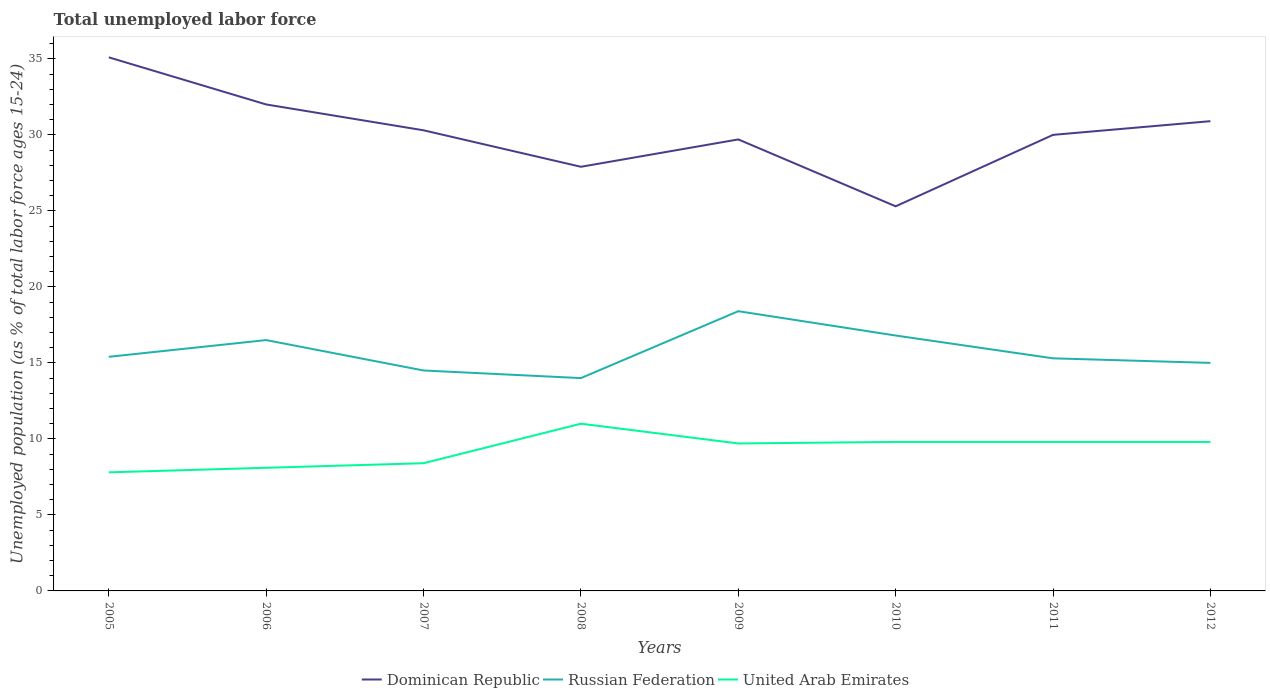Does the line corresponding to United Arab Emirates intersect with the line corresponding to Dominican Republic?
Your answer should be compact. No. Across all years, what is the maximum percentage of unemployed population in in Dominican Republic?
Your answer should be very brief. 25.3. In which year was the percentage of unemployed population in in United Arab Emirates maximum?
Give a very brief answer. 2005. What is the total percentage of unemployed population in in Dominican Republic in the graph?
Offer a terse response. 1.7. What is the difference between the highest and the second highest percentage of unemployed population in in Dominican Republic?
Make the answer very short. 9.8. Is the percentage of unemployed population in in United Arab Emirates strictly greater than the percentage of unemployed population in in Dominican Republic over the years?
Your answer should be compact. Yes. What is the difference between two consecutive major ticks on the Y-axis?
Offer a very short reply. 5. Does the graph contain grids?
Offer a very short reply. No. Where does the legend appear in the graph?
Make the answer very short. Bottom center. What is the title of the graph?
Provide a short and direct response. Total unemployed labor force. Does "Mexico" appear as one of the legend labels in the graph?
Your answer should be compact. No. What is the label or title of the Y-axis?
Your answer should be compact. Unemployed population (as % of total labor force ages 15-24). What is the Unemployed population (as % of total labor force ages 15-24) of Dominican Republic in 2005?
Offer a very short reply. 35.1. What is the Unemployed population (as % of total labor force ages 15-24) in Russian Federation in 2005?
Give a very brief answer. 15.4. What is the Unemployed population (as % of total labor force ages 15-24) in United Arab Emirates in 2005?
Make the answer very short. 7.8. What is the Unemployed population (as % of total labor force ages 15-24) in Russian Federation in 2006?
Give a very brief answer. 16.5. What is the Unemployed population (as % of total labor force ages 15-24) in United Arab Emirates in 2006?
Give a very brief answer. 8.1. What is the Unemployed population (as % of total labor force ages 15-24) of Dominican Republic in 2007?
Your response must be concise. 30.3. What is the Unemployed population (as % of total labor force ages 15-24) of Russian Federation in 2007?
Make the answer very short. 14.5. What is the Unemployed population (as % of total labor force ages 15-24) of United Arab Emirates in 2007?
Your answer should be compact. 8.4. What is the Unemployed population (as % of total labor force ages 15-24) of Dominican Republic in 2008?
Give a very brief answer. 27.9. What is the Unemployed population (as % of total labor force ages 15-24) in United Arab Emirates in 2008?
Provide a succinct answer. 11. What is the Unemployed population (as % of total labor force ages 15-24) in Dominican Republic in 2009?
Your answer should be very brief. 29.7. What is the Unemployed population (as % of total labor force ages 15-24) in Russian Federation in 2009?
Your answer should be very brief. 18.4. What is the Unemployed population (as % of total labor force ages 15-24) in United Arab Emirates in 2009?
Your response must be concise. 9.7. What is the Unemployed population (as % of total labor force ages 15-24) of Dominican Republic in 2010?
Keep it short and to the point. 25.3. What is the Unemployed population (as % of total labor force ages 15-24) of Russian Federation in 2010?
Your answer should be compact. 16.8. What is the Unemployed population (as % of total labor force ages 15-24) in United Arab Emirates in 2010?
Offer a very short reply. 9.8. What is the Unemployed population (as % of total labor force ages 15-24) of Dominican Republic in 2011?
Offer a terse response. 30. What is the Unemployed population (as % of total labor force ages 15-24) in Russian Federation in 2011?
Your response must be concise. 15.3. What is the Unemployed population (as % of total labor force ages 15-24) in United Arab Emirates in 2011?
Offer a very short reply. 9.8. What is the Unemployed population (as % of total labor force ages 15-24) in Dominican Republic in 2012?
Ensure brevity in your answer.  30.9. What is the Unemployed population (as % of total labor force ages 15-24) in Russian Federation in 2012?
Your response must be concise. 15. What is the Unemployed population (as % of total labor force ages 15-24) in United Arab Emirates in 2012?
Make the answer very short. 9.8. Across all years, what is the maximum Unemployed population (as % of total labor force ages 15-24) of Dominican Republic?
Offer a terse response. 35.1. Across all years, what is the maximum Unemployed population (as % of total labor force ages 15-24) of Russian Federation?
Give a very brief answer. 18.4. Across all years, what is the maximum Unemployed population (as % of total labor force ages 15-24) in United Arab Emirates?
Offer a terse response. 11. Across all years, what is the minimum Unemployed population (as % of total labor force ages 15-24) in Dominican Republic?
Provide a succinct answer. 25.3. Across all years, what is the minimum Unemployed population (as % of total labor force ages 15-24) in United Arab Emirates?
Offer a terse response. 7.8. What is the total Unemployed population (as % of total labor force ages 15-24) of Dominican Republic in the graph?
Give a very brief answer. 241.2. What is the total Unemployed population (as % of total labor force ages 15-24) of Russian Federation in the graph?
Provide a succinct answer. 125.9. What is the total Unemployed population (as % of total labor force ages 15-24) in United Arab Emirates in the graph?
Your response must be concise. 74.4. What is the difference between the Unemployed population (as % of total labor force ages 15-24) in Russian Federation in 2005 and that in 2006?
Offer a terse response. -1.1. What is the difference between the Unemployed population (as % of total labor force ages 15-24) of Russian Federation in 2005 and that in 2008?
Offer a terse response. 1.4. What is the difference between the Unemployed population (as % of total labor force ages 15-24) in United Arab Emirates in 2005 and that in 2008?
Provide a succinct answer. -3.2. What is the difference between the Unemployed population (as % of total labor force ages 15-24) of Russian Federation in 2005 and that in 2009?
Make the answer very short. -3. What is the difference between the Unemployed population (as % of total labor force ages 15-24) of United Arab Emirates in 2005 and that in 2009?
Ensure brevity in your answer.  -1.9. What is the difference between the Unemployed population (as % of total labor force ages 15-24) in Dominican Republic in 2005 and that in 2010?
Your response must be concise. 9.8. What is the difference between the Unemployed population (as % of total labor force ages 15-24) of Russian Federation in 2005 and that in 2010?
Offer a terse response. -1.4. What is the difference between the Unemployed population (as % of total labor force ages 15-24) in United Arab Emirates in 2005 and that in 2010?
Your response must be concise. -2. What is the difference between the Unemployed population (as % of total labor force ages 15-24) of Russian Federation in 2005 and that in 2011?
Your response must be concise. 0.1. What is the difference between the Unemployed population (as % of total labor force ages 15-24) of Dominican Republic in 2006 and that in 2007?
Your response must be concise. 1.7. What is the difference between the Unemployed population (as % of total labor force ages 15-24) in Russian Federation in 2006 and that in 2007?
Your answer should be compact. 2. What is the difference between the Unemployed population (as % of total labor force ages 15-24) in Russian Federation in 2006 and that in 2008?
Keep it short and to the point. 2.5. What is the difference between the Unemployed population (as % of total labor force ages 15-24) of United Arab Emirates in 2006 and that in 2008?
Keep it short and to the point. -2.9. What is the difference between the Unemployed population (as % of total labor force ages 15-24) in Russian Federation in 2006 and that in 2010?
Ensure brevity in your answer.  -0.3. What is the difference between the Unemployed population (as % of total labor force ages 15-24) of Russian Federation in 2006 and that in 2011?
Make the answer very short. 1.2. What is the difference between the Unemployed population (as % of total labor force ages 15-24) in United Arab Emirates in 2006 and that in 2011?
Provide a succinct answer. -1.7. What is the difference between the Unemployed population (as % of total labor force ages 15-24) in Russian Federation in 2006 and that in 2012?
Offer a terse response. 1.5. What is the difference between the Unemployed population (as % of total labor force ages 15-24) in Russian Federation in 2007 and that in 2008?
Keep it short and to the point. 0.5. What is the difference between the Unemployed population (as % of total labor force ages 15-24) in Dominican Republic in 2007 and that in 2010?
Your answer should be compact. 5. What is the difference between the Unemployed population (as % of total labor force ages 15-24) in United Arab Emirates in 2007 and that in 2010?
Ensure brevity in your answer.  -1.4. What is the difference between the Unemployed population (as % of total labor force ages 15-24) in Dominican Republic in 2007 and that in 2011?
Ensure brevity in your answer.  0.3. What is the difference between the Unemployed population (as % of total labor force ages 15-24) in Russian Federation in 2007 and that in 2011?
Your answer should be very brief. -0.8. What is the difference between the Unemployed population (as % of total labor force ages 15-24) of Dominican Republic in 2007 and that in 2012?
Ensure brevity in your answer.  -0.6. What is the difference between the Unemployed population (as % of total labor force ages 15-24) of Dominican Republic in 2008 and that in 2009?
Offer a very short reply. -1.8. What is the difference between the Unemployed population (as % of total labor force ages 15-24) of Russian Federation in 2008 and that in 2009?
Your answer should be very brief. -4.4. What is the difference between the Unemployed population (as % of total labor force ages 15-24) in United Arab Emirates in 2008 and that in 2009?
Ensure brevity in your answer.  1.3. What is the difference between the Unemployed population (as % of total labor force ages 15-24) of United Arab Emirates in 2008 and that in 2010?
Keep it short and to the point. 1.2. What is the difference between the Unemployed population (as % of total labor force ages 15-24) in Dominican Republic in 2008 and that in 2012?
Offer a very short reply. -3. What is the difference between the Unemployed population (as % of total labor force ages 15-24) in Russian Federation in 2008 and that in 2012?
Ensure brevity in your answer.  -1. What is the difference between the Unemployed population (as % of total labor force ages 15-24) of United Arab Emirates in 2008 and that in 2012?
Keep it short and to the point. 1.2. What is the difference between the Unemployed population (as % of total labor force ages 15-24) of Dominican Republic in 2009 and that in 2010?
Your answer should be compact. 4.4. What is the difference between the Unemployed population (as % of total labor force ages 15-24) of Russian Federation in 2009 and that in 2010?
Your response must be concise. 1.6. What is the difference between the Unemployed population (as % of total labor force ages 15-24) in Dominican Republic in 2009 and that in 2011?
Offer a very short reply. -0.3. What is the difference between the Unemployed population (as % of total labor force ages 15-24) of United Arab Emirates in 2009 and that in 2011?
Provide a succinct answer. -0.1. What is the difference between the Unemployed population (as % of total labor force ages 15-24) in Dominican Republic in 2009 and that in 2012?
Provide a succinct answer. -1.2. What is the difference between the Unemployed population (as % of total labor force ages 15-24) of United Arab Emirates in 2009 and that in 2012?
Offer a very short reply. -0.1. What is the difference between the Unemployed population (as % of total labor force ages 15-24) of Dominican Republic in 2010 and that in 2011?
Your answer should be compact. -4.7. What is the difference between the Unemployed population (as % of total labor force ages 15-24) in United Arab Emirates in 2010 and that in 2011?
Your answer should be very brief. 0. What is the difference between the Unemployed population (as % of total labor force ages 15-24) of Dominican Republic in 2010 and that in 2012?
Your response must be concise. -5.6. What is the difference between the Unemployed population (as % of total labor force ages 15-24) in Dominican Republic in 2011 and that in 2012?
Provide a short and direct response. -0.9. What is the difference between the Unemployed population (as % of total labor force ages 15-24) of Russian Federation in 2011 and that in 2012?
Keep it short and to the point. 0.3. What is the difference between the Unemployed population (as % of total labor force ages 15-24) of Dominican Republic in 2005 and the Unemployed population (as % of total labor force ages 15-24) of United Arab Emirates in 2006?
Your answer should be compact. 27. What is the difference between the Unemployed population (as % of total labor force ages 15-24) in Dominican Republic in 2005 and the Unemployed population (as % of total labor force ages 15-24) in Russian Federation in 2007?
Make the answer very short. 20.6. What is the difference between the Unemployed population (as % of total labor force ages 15-24) of Dominican Republic in 2005 and the Unemployed population (as % of total labor force ages 15-24) of United Arab Emirates in 2007?
Your answer should be very brief. 26.7. What is the difference between the Unemployed population (as % of total labor force ages 15-24) in Dominican Republic in 2005 and the Unemployed population (as % of total labor force ages 15-24) in Russian Federation in 2008?
Your response must be concise. 21.1. What is the difference between the Unemployed population (as % of total labor force ages 15-24) of Dominican Republic in 2005 and the Unemployed population (as % of total labor force ages 15-24) of United Arab Emirates in 2008?
Your answer should be compact. 24.1. What is the difference between the Unemployed population (as % of total labor force ages 15-24) in Russian Federation in 2005 and the Unemployed population (as % of total labor force ages 15-24) in United Arab Emirates in 2008?
Offer a very short reply. 4.4. What is the difference between the Unemployed population (as % of total labor force ages 15-24) in Dominican Republic in 2005 and the Unemployed population (as % of total labor force ages 15-24) in Russian Federation in 2009?
Keep it short and to the point. 16.7. What is the difference between the Unemployed population (as % of total labor force ages 15-24) of Dominican Republic in 2005 and the Unemployed population (as % of total labor force ages 15-24) of United Arab Emirates in 2009?
Your response must be concise. 25.4. What is the difference between the Unemployed population (as % of total labor force ages 15-24) in Russian Federation in 2005 and the Unemployed population (as % of total labor force ages 15-24) in United Arab Emirates in 2009?
Provide a succinct answer. 5.7. What is the difference between the Unemployed population (as % of total labor force ages 15-24) of Dominican Republic in 2005 and the Unemployed population (as % of total labor force ages 15-24) of United Arab Emirates in 2010?
Offer a very short reply. 25.3. What is the difference between the Unemployed population (as % of total labor force ages 15-24) of Dominican Republic in 2005 and the Unemployed population (as % of total labor force ages 15-24) of Russian Federation in 2011?
Provide a succinct answer. 19.8. What is the difference between the Unemployed population (as % of total labor force ages 15-24) in Dominican Republic in 2005 and the Unemployed population (as % of total labor force ages 15-24) in United Arab Emirates in 2011?
Provide a succinct answer. 25.3. What is the difference between the Unemployed population (as % of total labor force ages 15-24) of Russian Federation in 2005 and the Unemployed population (as % of total labor force ages 15-24) of United Arab Emirates in 2011?
Your answer should be very brief. 5.6. What is the difference between the Unemployed population (as % of total labor force ages 15-24) in Dominican Republic in 2005 and the Unemployed population (as % of total labor force ages 15-24) in Russian Federation in 2012?
Provide a short and direct response. 20.1. What is the difference between the Unemployed population (as % of total labor force ages 15-24) in Dominican Republic in 2005 and the Unemployed population (as % of total labor force ages 15-24) in United Arab Emirates in 2012?
Your response must be concise. 25.3. What is the difference between the Unemployed population (as % of total labor force ages 15-24) in Russian Federation in 2005 and the Unemployed population (as % of total labor force ages 15-24) in United Arab Emirates in 2012?
Keep it short and to the point. 5.6. What is the difference between the Unemployed population (as % of total labor force ages 15-24) in Dominican Republic in 2006 and the Unemployed population (as % of total labor force ages 15-24) in Russian Federation in 2007?
Give a very brief answer. 17.5. What is the difference between the Unemployed population (as % of total labor force ages 15-24) in Dominican Republic in 2006 and the Unemployed population (as % of total labor force ages 15-24) in United Arab Emirates in 2007?
Your answer should be very brief. 23.6. What is the difference between the Unemployed population (as % of total labor force ages 15-24) of Russian Federation in 2006 and the Unemployed population (as % of total labor force ages 15-24) of United Arab Emirates in 2007?
Provide a succinct answer. 8.1. What is the difference between the Unemployed population (as % of total labor force ages 15-24) in Dominican Republic in 2006 and the Unemployed population (as % of total labor force ages 15-24) in Russian Federation in 2009?
Provide a short and direct response. 13.6. What is the difference between the Unemployed population (as % of total labor force ages 15-24) of Dominican Republic in 2006 and the Unemployed population (as % of total labor force ages 15-24) of United Arab Emirates in 2009?
Ensure brevity in your answer.  22.3. What is the difference between the Unemployed population (as % of total labor force ages 15-24) in Russian Federation in 2006 and the Unemployed population (as % of total labor force ages 15-24) in United Arab Emirates in 2009?
Provide a succinct answer. 6.8. What is the difference between the Unemployed population (as % of total labor force ages 15-24) in Dominican Republic in 2006 and the Unemployed population (as % of total labor force ages 15-24) in United Arab Emirates in 2010?
Ensure brevity in your answer.  22.2. What is the difference between the Unemployed population (as % of total labor force ages 15-24) in Russian Federation in 2006 and the Unemployed population (as % of total labor force ages 15-24) in United Arab Emirates in 2010?
Your answer should be compact. 6.7. What is the difference between the Unemployed population (as % of total labor force ages 15-24) in Dominican Republic in 2006 and the Unemployed population (as % of total labor force ages 15-24) in Russian Federation in 2011?
Provide a succinct answer. 16.7. What is the difference between the Unemployed population (as % of total labor force ages 15-24) of Dominican Republic in 2006 and the Unemployed population (as % of total labor force ages 15-24) of United Arab Emirates in 2011?
Offer a very short reply. 22.2. What is the difference between the Unemployed population (as % of total labor force ages 15-24) in Russian Federation in 2006 and the Unemployed population (as % of total labor force ages 15-24) in United Arab Emirates in 2011?
Your answer should be very brief. 6.7. What is the difference between the Unemployed population (as % of total labor force ages 15-24) in Dominican Republic in 2006 and the Unemployed population (as % of total labor force ages 15-24) in Russian Federation in 2012?
Ensure brevity in your answer.  17. What is the difference between the Unemployed population (as % of total labor force ages 15-24) in Dominican Republic in 2006 and the Unemployed population (as % of total labor force ages 15-24) in United Arab Emirates in 2012?
Your response must be concise. 22.2. What is the difference between the Unemployed population (as % of total labor force ages 15-24) in Russian Federation in 2006 and the Unemployed population (as % of total labor force ages 15-24) in United Arab Emirates in 2012?
Keep it short and to the point. 6.7. What is the difference between the Unemployed population (as % of total labor force ages 15-24) of Dominican Republic in 2007 and the Unemployed population (as % of total labor force ages 15-24) of United Arab Emirates in 2008?
Ensure brevity in your answer.  19.3. What is the difference between the Unemployed population (as % of total labor force ages 15-24) of Dominican Republic in 2007 and the Unemployed population (as % of total labor force ages 15-24) of United Arab Emirates in 2009?
Provide a short and direct response. 20.6. What is the difference between the Unemployed population (as % of total labor force ages 15-24) in Dominican Republic in 2007 and the Unemployed population (as % of total labor force ages 15-24) in Russian Federation in 2010?
Your response must be concise. 13.5. What is the difference between the Unemployed population (as % of total labor force ages 15-24) of Dominican Republic in 2007 and the Unemployed population (as % of total labor force ages 15-24) of United Arab Emirates in 2010?
Keep it short and to the point. 20.5. What is the difference between the Unemployed population (as % of total labor force ages 15-24) in Dominican Republic in 2007 and the Unemployed population (as % of total labor force ages 15-24) in Russian Federation in 2012?
Your answer should be very brief. 15.3. What is the difference between the Unemployed population (as % of total labor force ages 15-24) in Dominican Republic in 2008 and the Unemployed population (as % of total labor force ages 15-24) in Russian Federation in 2010?
Make the answer very short. 11.1. What is the difference between the Unemployed population (as % of total labor force ages 15-24) of Russian Federation in 2008 and the Unemployed population (as % of total labor force ages 15-24) of United Arab Emirates in 2010?
Your answer should be very brief. 4.2. What is the difference between the Unemployed population (as % of total labor force ages 15-24) in Dominican Republic in 2008 and the Unemployed population (as % of total labor force ages 15-24) in United Arab Emirates in 2011?
Make the answer very short. 18.1. What is the difference between the Unemployed population (as % of total labor force ages 15-24) in Russian Federation in 2008 and the Unemployed population (as % of total labor force ages 15-24) in United Arab Emirates in 2011?
Offer a very short reply. 4.2. What is the difference between the Unemployed population (as % of total labor force ages 15-24) in Russian Federation in 2008 and the Unemployed population (as % of total labor force ages 15-24) in United Arab Emirates in 2012?
Your answer should be compact. 4.2. What is the difference between the Unemployed population (as % of total labor force ages 15-24) of Dominican Republic in 2009 and the Unemployed population (as % of total labor force ages 15-24) of United Arab Emirates in 2010?
Your answer should be very brief. 19.9. What is the difference between the Unemployed population (as % of total labor force ages 15-24) of Russian Federation in 2009 and the Unemployed population (as % of total labor force ages 15-24) of United Arab Emirates in 2010?
Your answer should be compact. 8.6. What is the difference between the Unemployed population (as % of total labor force ages 15-24) of Dominican Republic in 2009 and the Unemployed population (as % of total labor force ages 15-24) of United Arab Emirates in 2012?
Offer a terse response. 19.9. What is the difference between the Unemployed population (as % of total labor force ages 15-24) in Russian Federation in 2009 and the Unemployed population (as % of total labor force ages 15-24) in United Arab Emirates in 2012?
Offer a terse response. 8.6. What is the difference between the Unemployed population (as % of total labor force ages 15-24) in Dominican Republic in 2010 and the Unemployed population (as % of total labor force ages 15-24) in Russian Federation in 2011?
Ensure brevity in your answer.  10. What is the difference between the Unemployed population (as % of total labor force ages 15-24) in Dominican Republic in 2010 and the Unemployed population (as % of total labor force ages 15-24) in United Arab Emirates in 2011?
Give a very brief answer. 15.5. What is the difference between the Unemployed population (as % of total labor force ages 15-24) in Dominican Republic in 2011 and the Unemployed population (as % of total labor force ages 15-24) in United Arab Emirates in 2012?
Offer a very short reply. 20.2. What is the difference between the Unemployed population (as % of total labor force ages 15-24) in Russian Federation in 2011 and the Unemployed population (as % of total labor force ages 15-24) in United Arab Emirates in 2012?
Ensure brevity in your answer.  5.5. What is the average Unemployed population (as % of total labor force ages 15-24) in Dominican Republic per year?
Offer a terse response. 30.15. What is the average Unemployed population (as % of total labor force ages 15-24) in Russian Federation per year?
Provide a succinct answer. 15.74. What is the average Unemployed population (as % of total labor force ages 15-24) in United Arab Emirates per year?
Offer a terse response. 9.3. In the year 2005, what is the difference between the Unemployed population (as % of total labor force ages 15-24) in Dominican Republic and Unemployed population (as % of total labor force ages 15-24) in United Arab Emirates?
Provide a succinct answer. 27.3. In the year 2006, what is the difference between the Unemployed population (as % of total labor force ages 15-24) of Dominican Republic and Unemployed population (as % of total labor force ages 15-24) of United Arab Emirates?
Provide a succinct answer. 23.9. In the year 2006, what is the difference between the Unemployed population (as % of total labor force ages 15-24) in Russian Federation and Unemployed population (as % of total labor force ages 15-24) in United Arab Emirates?
Give a very brief answer. 8.4. In the year 2007, what is the difference between the Unemployed population (as % of total labor force ages 15-24) of Dominican Republic and Unemployed population (as % of total labor force ages 15-24) of Russian Federation?
Offer a very short reply. 15.8. In the year 2007, what is the difference between the Unemployed population (as % of total labor force ages 15-24) in Dominican Republic and Unemployed population (as % of total labor force ages 15-24) in United Arab Emirates?
Your answer should be very brief. 21.9. In the year 2007, what is the difference between the Unemployed population (as % of total labor force ages 15-24) in Russian Federation and Unemployed population (as % of total labor force ages 15-24) in United Arab Emirates?
Provide a succinct answer. 6.1. In the year 2008, what is the difference between the Unemployed population (as % of total labor force ages 15-24) in Dominican Republic and Unemployed population (as % of total labor force ages 15-24) in Russian Federation?
Give a very brief answer. 13.9. In the year 2009, what is the difference between the Unemployed population (as % of total labor force ages 15-24) in Dominican Republic and Unemployed population (as % of total labor force ages 15-24) in Russian Federation?
Provide a short and direct response. 11.3. In the year 2009, what is the difference between the Unemployed population (as % of total labor force ages 15-24) of Dominican Republic and Unemployed population (as % of total labor force ages 15-24) of United Arab Emirates?
Provide a short and direct response. 20. In the year 2009, what is the difference between the Unemployed population (as % of total labor force ages 15-24) of Russian Federation and Unemployed population (as % of total labor force ages 15-24) of United Arab Emirates?
Your response must be concise. 8.7. In the year 2011, what is the difference between the Unemployed population (as % of total labor force ages 15-24) in Dominican Republic and Unemployed population (as % of total labor force ages 15-24) in Russian Federation?
Offer a very short reply. 14.7. In the year 2011, what is the difference between the Unemployed population (as % of total labor force ages 15-24) in Dominican Republic and Unemployed population (as % of total labor force ages 15-24) in United Arab Emirates?
Provide a succinct answer. 20.2. In the year 2012, what is the difference between the Unemployed population (as % of total labor force ages 15-24) of Dominican Republic and Unemployed population (as % of total labor force ages 15-24) of United Arab Emirates?
Offer a terse response. 21.1. In the year 2012, what is the difference between the Unemployed population (as % of total labor force ages 15-24) of Russian Federation and Unemployed population (as % of total labor force ages 15-24) of United Arab Emirates?
Make the answer very short. 5.2. What is the ratio of the Unemployed population (as % of total labor force ages 15-24) of Dominican Republic in 2005 to that in 2006?
Your answer should be compact. 1.1. What is the ratio of the Unemployed population (as % of total labor force ages 15-24) in United Arab Emirates in 2005 to that in 2006?
Your response must be concise. 0.96. What is the ratio of the Unemployed population (as % of total labor force ages 15-24) of Dominican Republic in 2005 to that in 2007?
Your answer should be very brief. 1.16. What is the ratio of the Unemployed population (as % of total labor force ages 15-24) of Russian Federation in 2005 to that in 2007?
Your answer should be very brief. 1.06. What is the ratio of the Unemployed population (as % of total labor force ages 15-24) of United Arab Emirates in 2005 to that in 2007?
Give a very brief answer. 0.93. What is the ratio of the Unemployed population (as % of total labor force ages 15-24) in Dominican Republic in 2005 to that in 2008?
Your response must be concise. 1.26. What is the ratio of the Unemployed population (as % of total labor force ages 15-24) in United Arab Emirates in 2005 to that in 2008?
Give a very brief answer. 0.71. What is the ratio of the Unemployed population (as % of total labor force ages 15-24) of Dominican Republic in 2005 to that in 2009?
Give a very brief answer. 1.18. What is the ratio of the Unemployed population (as % of total labor force ages 15-24) in Russian Federation in 2005 to that in 2009?
Your response must be concise. 0.84. What is the ratio of the Unemployed population (as % of total labor force ages 15-24) in United Arab Emirates in 2005 to that in 2009?
Your answer should be compact. 0.8. What is the ratio of the Unemployed population (as % of total labor force ages 15-24) in Dominican Republic in 2005 to that in 2010?
Ensure brevity in your answer.  1.39. What is the ratio of the Unemployed population (as % of total labor force ages 15-24) in United Arab Emirates in 2005 to that in 2010?
Provide a short and direct response. 0.8. What is the ratio of the Unemployed population (as % of total labor force ages 15-24) of Dominican Republic in 2005 to that in 2011?
Your answer should be very brief. 1.17. What is the ratio of the Unemployed population (as % of total labor force ages 15-24) of Russian Federation in 2005 to that in 2011?
Give a very brief answer. 1.01. What is the ratio of the Unemployed population (as % of total labor force ages 15-24) of United Arab Emirates in 2005 to that in 2011?
Your response must be concise. 0.8. What is the ratio of the Unemployed population (as % of total labor force ages 15-24) of Dominican Republic in 2005 to that in 2012?
Provide a short and direct response. 1.14. What is the ratio of the Unemployed population (as % of total labor force ages 15-24) in Russian Federation in 2005 to that in 2012?
Keep it short and to the point. 1.03. What is the ratio of the Unemployed population (as % of total labor force ages 15-24) of United Arab Emirates in 2005 to that in 2012?
Ensure brevity in your answer.  0.8. What is the ratio of the Unemployed population (as % of total labor force ages 15-24) in Dominican Republic in 2006 to that in 2007?
Offer a terse response. 1.06. What is the ratio of the Unemployed population (as % of total labor force ages 15-24) of Russian Federation in 2006 to that in 2007?
Offer a terse response. 1.14. What is the ratio of the Unemployed population (as % of total labor force ages 15-24) in Dominican Republic in 2006 to that in 2008?
Give a very brief answer. 1.15. What is the ratio of the Unemployed population (as % of total labor force ages 15-24) in Russian Federation in 2006 to that in 2008?
Your answer should be very brief. 1.18. What is the ratio of the Unemployed population (as % of total labor force ages 15-24) in United Arab Emirates in 2006 to that in 2008?
Your answer should be compact. 0.74. What is the ratio of the Unemployed population (as % of total labor force ages 15-24) in Dominican Republic in 2006 to that in 2009?
Your response must be concise. 1.08. What is the ratio of the Unemployed population (as % of total labor force ages 15-24) in Russian Federation in 2006 to that in 2009?
Keep it short and to the point. 0.9. What is the ratio of the Unemployed population (as % of total labor force ages 15-24) of United Arab Emirates in 2006 to that in 2009?
Keep it short and to the point. 0.84. What is the ratio of the Unemployed population (as % of total labor force ages 15-24) in Dominican Republic in 2006 to that in 2010?
Offer a terse response. 1.26. What is the ratio of the Unemployed population (as % of total labor force ages 15-24) of Russian Federation in 2006 to that in 2010?
Keep it short and to the point. 0.98. What is the ratio of the Unemployed population (as % of total labor force ages 15-24) in United Arab Emirates in 2006 to that in 2010?
Your answer should be compact. 0.83. What is the ratio of the Unemployed population (as % of total labor force ages 15-24) in Dominican Republic in 2006 to that in 2011?
Offer a very short reply. 1.07. What is the ratio of the Unemployed population (as % of total labor force ages 15-24) of Russian Federation in 2006 to that in 2011?
Your response must be concise. 1.08. What is the ratio of the Unemployed population (as % of total labor force ages 15-24) of United Arab Emirates in 2006 to that in 2011?
Keep it short and to the point. 0.83. What is the ratio of the Unemployed population (as % of total labor force ages 15-24) of Dominican Republic in 2006 to that in 2012?
Your answer should be very brief. 1.04. What is the ratio of the Unemployed population (as % of total labor force ages 15-24) in Russian Federation in 2006 to that in 2012?
Ensure brevity in your answer.  1.1. What is the ratio of the Unemployed population (as % of total labor force ages 15-24) of United Arab Emirates in 2006 to that in 2012?
Offer a very short reply. 0.83. What is the ratio of the Unemployed population (as % of total labor force ages 15-24) in Dominican Republic in 2007 to that in 2008?
Give a very brief answer. 1.09. What is the ratio of the Unemployed population (as % of total labor force ages 15-24) in Russian Federation in 2007 to that in 2008?
Offer a very short reply. 1.04. What is the ratio of the Unemployed population (as % of total labor force ages 15-24) in United Arab Emirates in 2007 to that in 2008?
Offer a terse response. 0.76. What is the ratio of the Unemployed population (as % of total labor force ages 15-24) in Dominican Republic in 2007 to that in 2009?
Give a very brief answer. 1.02. What is the ratio of the Unemployed population (as % of total labor force ages 15-24) in Russian Federation in 2007 to that in 2009?
Your answer should be very brief. 0.79. What is the ratio of the Unemployed population (as % of total labor force ages 15-24) in United Arab Emirates in 2007 to that in 2009?
Keep it short and to the point. 0.87. What is the ratio of the Unemployed population (as % of total labor force ages 15-24) in Dominican Republic in 2007 to that in 2010?
Your answer should be very brief. 1.2. What is the ratio of the Unemployed population (as % of total labor force ages 15-24) in Russian Federation in 2007 to that in 2010?
Your response must be concise. 0.86. What is the ratio of the Unemployed population (as % of total labor force ages 15-24) in Dominican Republic in 2007 to that in 2011?
Ensure brevity in your answer.  1.01. What is the ratio of the Unemployed population (as % of total labor force ages 15-24) of Russian Federation in 2007 to that in 2011?
Provide a succinct answer. 0.95. What is the ratio of the Unemployed population (as % of total labor force ages 15-24) in Dominican Republic in 2007 to that in 2012?
Ensure brevity in your answer.  0.98. What is the ratio of the Unemployed population (as % of total labor force ages 15-24) of Russian Federation in 2007 to that in 2012?
Your answer should be compact. 0.97. What is the ratio of the Unemployed population (as % of total labor force ages 15-24) of United Arab Emirates in 2007 to that in 2012?
Provide a short and direct response. 0.86. What is the ratio of the Unemployed population (as % of total labor force ages 15-24) of Dominican Republic in 2008 to that in 2009?
Your response must be concise. 0.94. What is the ratio of the Unemployed population (as % of total labor force ages 15-24) of Russian Federation in 2008 to that in 2009?
Offer a terse response. 0.76. What is the ratio of the Unemployed population (as % of total labor force ages 15-24) in United Arab Emirates in 2008 to that in 2009?
Keep it short and to the point. 1.13. What is the ratio of the Unemployed population (as % of total labor force ages 15-24) in Dominican Republic in 2008 to that in 2010?
Ensure brevity in your answer.  1.1. What is the ratio of the Unemployed population (as % of total labor force ages 15-24) in United Arab Emirates in 2008 to that in 2010?
Your answer should be compact. 1.12. What is the ratio of the Unemployed population (as % of total labor force ages 15-24) in Dominican Republic in 2008 to that in 2011?
Your answer should be very brief. 0.93. What is the ratio of the Unemployed population (as % of total labor force ages 15-24) of Russian Federation in 2008 to that in 2011?
Provide a short and direct response. 0.92. What is the ratio of the Unemployed population (as % of total labor force ages 15-24) of United Arab Emirates in 2008 to that in 2011?
Ensure brevity in your answer.  1.12. What is the ratio of the Unemployed population (as % of total labor force ages 15-24) of Dominican Republic in 2008 to that in 2012?
Offer a very short reply. 0.9. What is the ratio of the Unemployed population (as % of total labor force ages 15-24) in United Arab Emirates in 2008 to that in 2012?
Provide a short and direct response. 1.12. What is the ratio of the Unemployed population (as % of total labor force ages 15-24) in Dominican Republic in 2009 to that in 2010?
Make the answer very short. 1.17. What is the ratio of the Unemployed population (as % of total labor force ages 15-24) in Russian Federation in 2009 to that in 2010?
Your answer should be very brief. 1.1. What is the ratio of the Unemployed population (as % of total labor force ages 15-24) of Russian Federation in 2009 to that in 2011?
Your answer should be very brief. 1.2. What is the ratio of the Unemployed population (as % of total labor force ages 15-24) in Dominican Republic in 2009 to that in 2012?
Provide a succinct answer. 0.96. What is the ratio of the Unemployed population (as % of total labor force ages 15-24) in Russian Federation in 2009 to that in 2012?
Give a very brief answer. 1.23. What is the ratio of the Unemployed population (as % of total labor force ages 15-24) in United Arab Emirates in 2009 to that in 2012?
Provide a short and direct response. 0.99. What is the ratio of the Unemployed population (as % of total labor force ages 15-24) of Dominican Republic in 2010 to that in 2011?
Your answer should be compact. 0.84. What is the ratio of the Unemployed population (as % of total labor force ages 15-24) in Russian Federation in 2010 to that in 2011?
Provide a short and direct response. 1.1. What is the ratio of the Unemployed population (as % of total labor force ages 15-24) in United Arab Emirates in 2010 to that in 2011?
Provide a succinct answer. 1. What is the ratio of the Unemployed population (as % of total labor force ages 15-24) in Dominican Republic in 2010 to that in 2012?
Provide a short and direct response. 0.82. What is the ratio of the Unemployed population (as % of total labor force ages 15-24) in Russian Federation in 2010 to that in 2012?
Provide a short and direct response. 1.12. What is the ratio of the Unemployed population (as % of total labor force ages 15-24) of Dominican Republic in 2011 to that in 2012?
Keep it short and to the point. 0.97. What is the ratio of the Unemployed population (as % of total labor force ages 15-24) of United Arab Emirates in 2011 to that in 2012?
Offer a terse response. 1. What is the difference between the highest and the second highest Unemployed population (as % of total labor force ages 15-24) of Russian Federation?
Make the answer very short. 1.6. What is the difference between the highest and the second highest Unemployed population (as % of total labor force ages 15-24) in United Arab Emirates?
Provide a short and direct response. 1.2. What is the difference between the highest and the lowest Unemployed population (as % of total labor force ages 15-24) of Dominican Republic?
Provide a short and direct response. 9.8. What is the difference between the highest and the lowest Unemployed population (as % of total labor force ages 15-24) of United Arab Emirates?
Give a very brief answer. 3.2. 